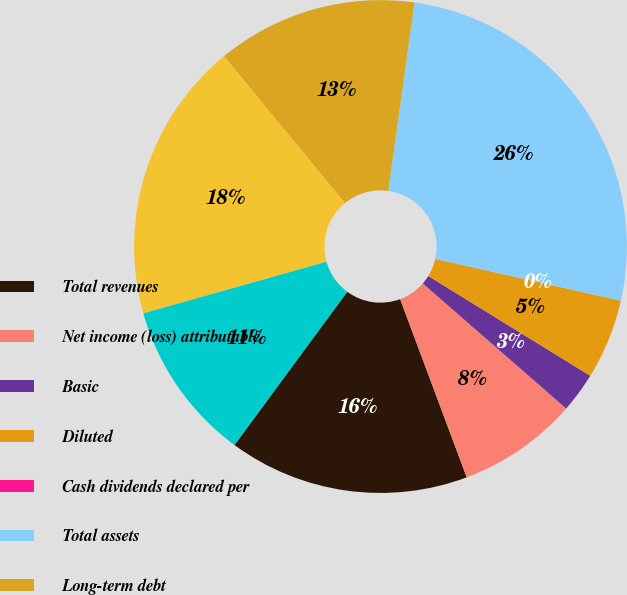<chart> <loc_0><loc_0><loc_500><loc_500><pie_chart><fcel>Total revenues<fcel>Net income (loss) attributable<fcel>Basic<fcel>Diluted<fcel>Cash dividends declared per<fcel>Total assets<fcel>Long-term debt<fcel>Total equity<fcel>Common shares outstanding<nl><fcel>15.79%<fcel>7.89%<fcel>2.63%<fcel>5.26%<fcel>0.0%<fcel>26.32%<fcel>13.16%<fcel>18.42%<fcel>10.53%<nl></chart> 